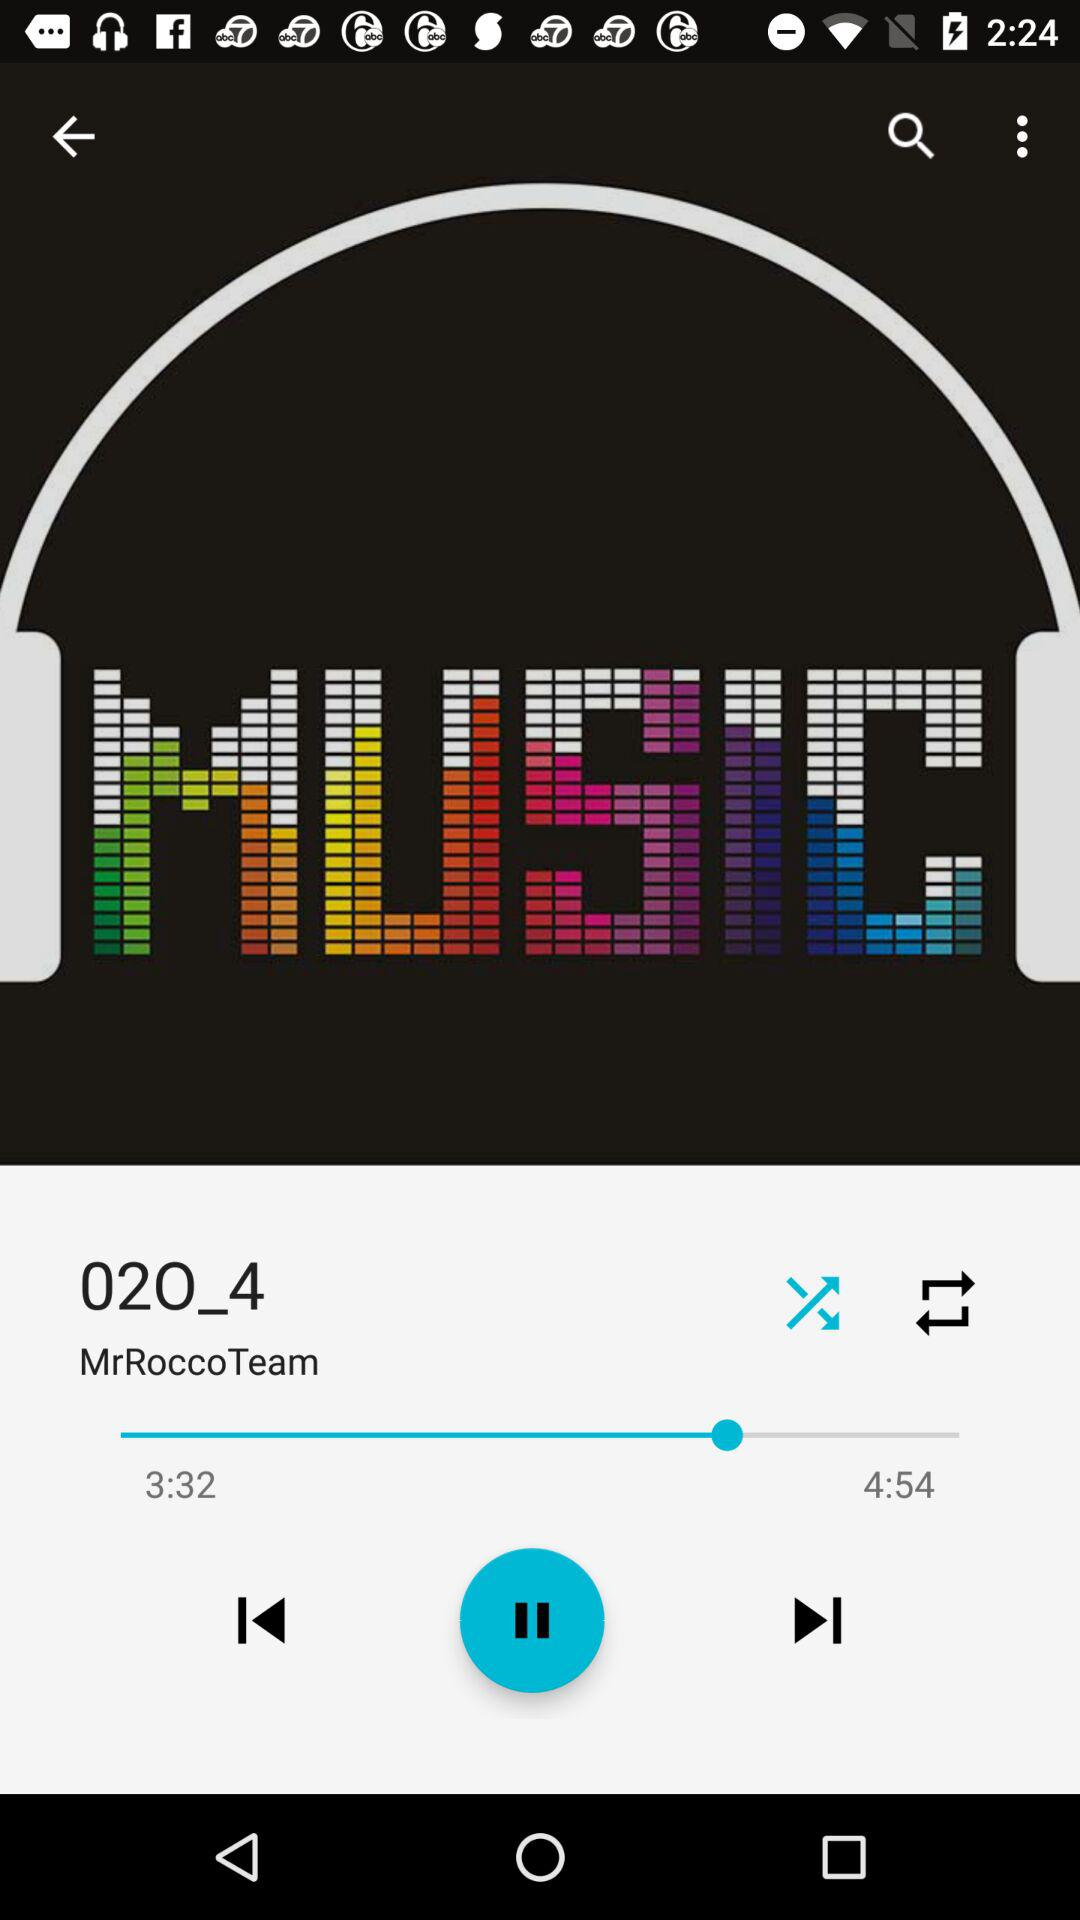What is the duration of the song? The duration of the song is 4 minutes and 54 seconds. 